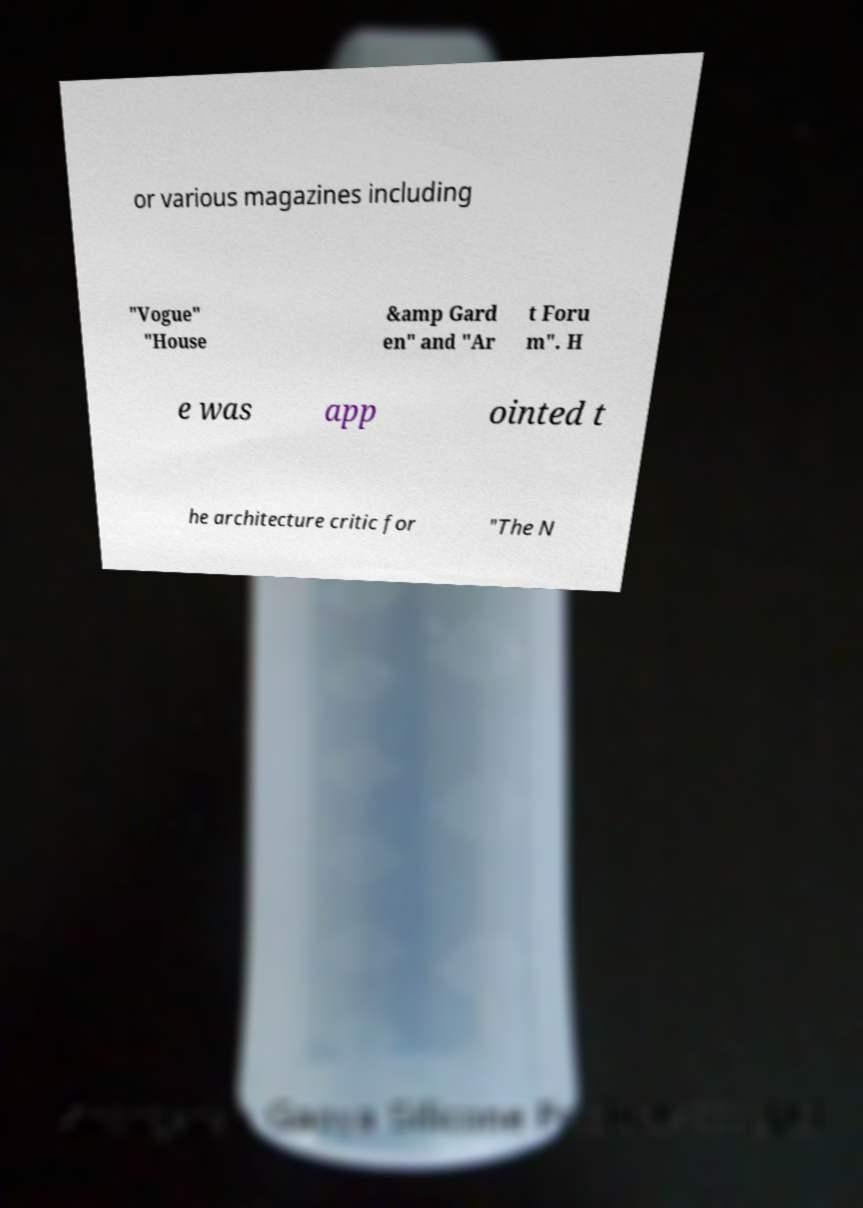I need the written content from this picture converted into text. Can you do that? or various magazines including "Vogue" "House &amp Gard en" and "Ar t Foru m". H e was app ointed t he architecture critic for "The N 